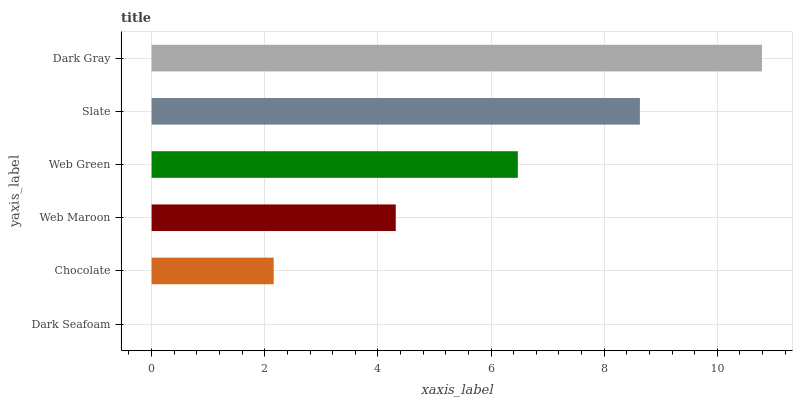Is Dark Seafoam the minimum?
Answer yes or no. Yes. Is Dark Gray the maximum?
Answer yes or no. Yes. Is Chocolate the minimum?
Answer yes or no. No. Is Chocolate the maximum?
Answer yes or no. No. Is Chocolate greater than Dark Seafoam?
Answer yes or no. Yes. Is Dark Seafoam less than Chocolate?
Answer yes or no. Yes. Is Dark Seafoam greater than Chocolate?
Answer yes or no. No. Is Chocolate less than Dark Seafoam?
Answer yes or no. No. Is Web Green the high median?
Answer yes or no. Yes. Is Web Maroon the low median?
Answer yes or no. Yes. Is Dark Gray the high median?
Answer yes or no. No. Is Web Green the low median?
Answer yes or no. No. 